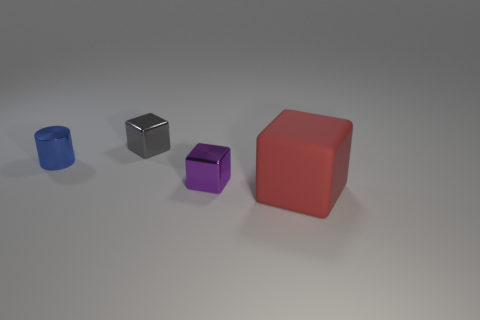Are the big object and the small object behind the small blue shiny cylinder made of the same material?
Give a very brief answer. No. What is the shape of the thing that is to the right of the metallic block right of the small gray object?
Offer a very short reply. Cube. Is the color of the large cube the same as the cube behind the tiny blue cylinder?
Provide a short and direct response. No. Are there any other things that are the same material as the blue cylinder?
Your answer should be very brief. Yes. What shape is the matte object?
Offer a terse response. Cube. What is the size of the block that is left of the tiny purple shiny object that is in front of the small gray thing?
Your response must be concise. Small. Are there an equal number of blocks that are on the left side of the cylinder and metal blocks that are in front of the small purple metallic thing?
Provide a short and direct response. Yes. What material is the cube that is both in front of the tiny blue object and behind the red thing?
Your answer should be very brief. Metal. There is a purple cube; is its size the same as the thing right of the purple object?
Offer a very short reply. No. What number of other things are there of the same color as the big block?
Offer a terse response. 0. 